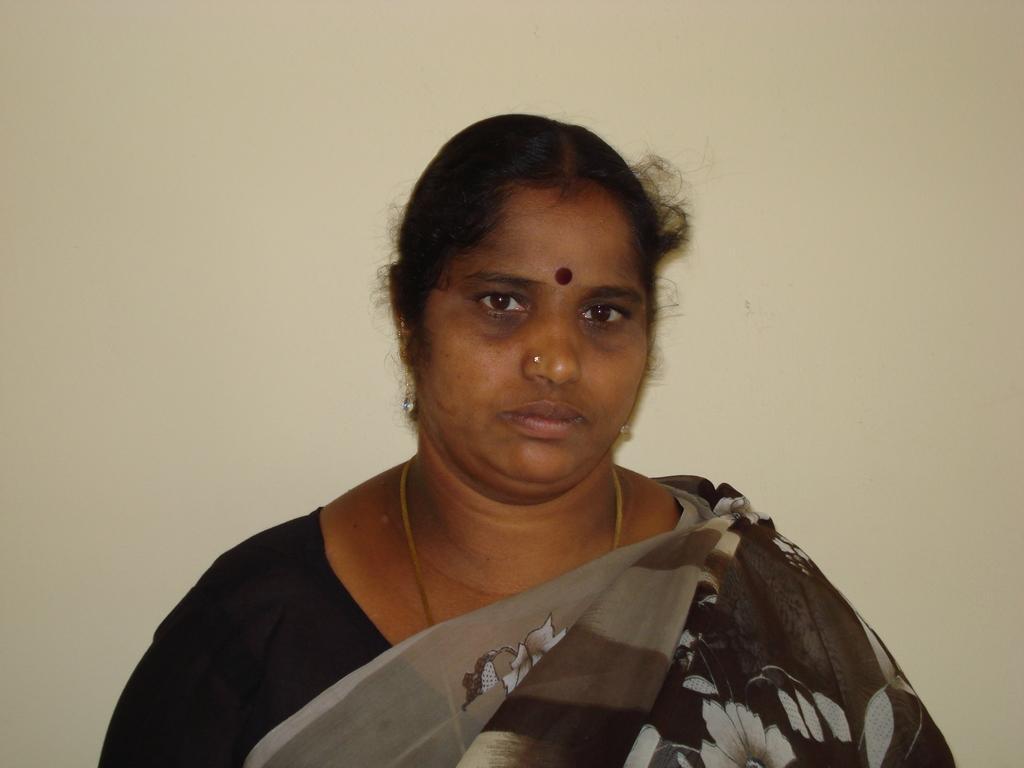Could you give a brief overview of what you see in this image? In the center of the image there is a lady wearing a saree. In the background of the image there is a wall. 